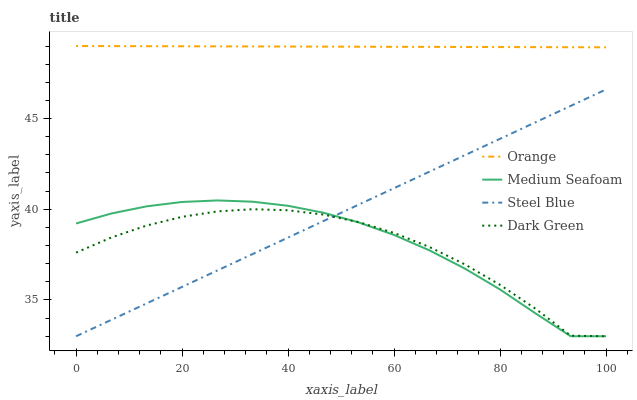Does Dark Green have the minimum area under the curve?
Answer yes or no. Yes. Does Orange have the maximum area under the curve?
Answer yes or no. Yes. Does Medium Seafoam have the minimum area under the curve?
Answer yes or no. No. Does Medium Seafoam have the maximum area under the curve?
Answer yes or no. No. Is Orange the smoothest?
Answer yes or no. Yes. Is Dark Green the roughest?
Answer yes or no. Yes. Is Medium Seafoam the smoothest?
Answer yes or no. No. Is Medium Seafoam the roughest?
Answer yes or no. No. Does Dark Green have the lowest value?
Answer yes or no. Yes. Does Orange have the highest value?
Answer yes or no. Yes. Does Medium Seafoam have the highest value?
Answer yes or no. No. Is Steel Blue less than Orange?
Answer yes or no. Yes. Is Orange greater than Steel Blue?
Answer yes or no. Yes. Does Dark Green intersect Steel Blue?
Answer yes or no. Yes. Is Dark Green less than Steel Blue?
Answer yes or no. No. Is Dark Green greater than Steel Blue?
Answer yes or no. No. Does Steel Blue intersect Orange?
Answer yes or no. No. 